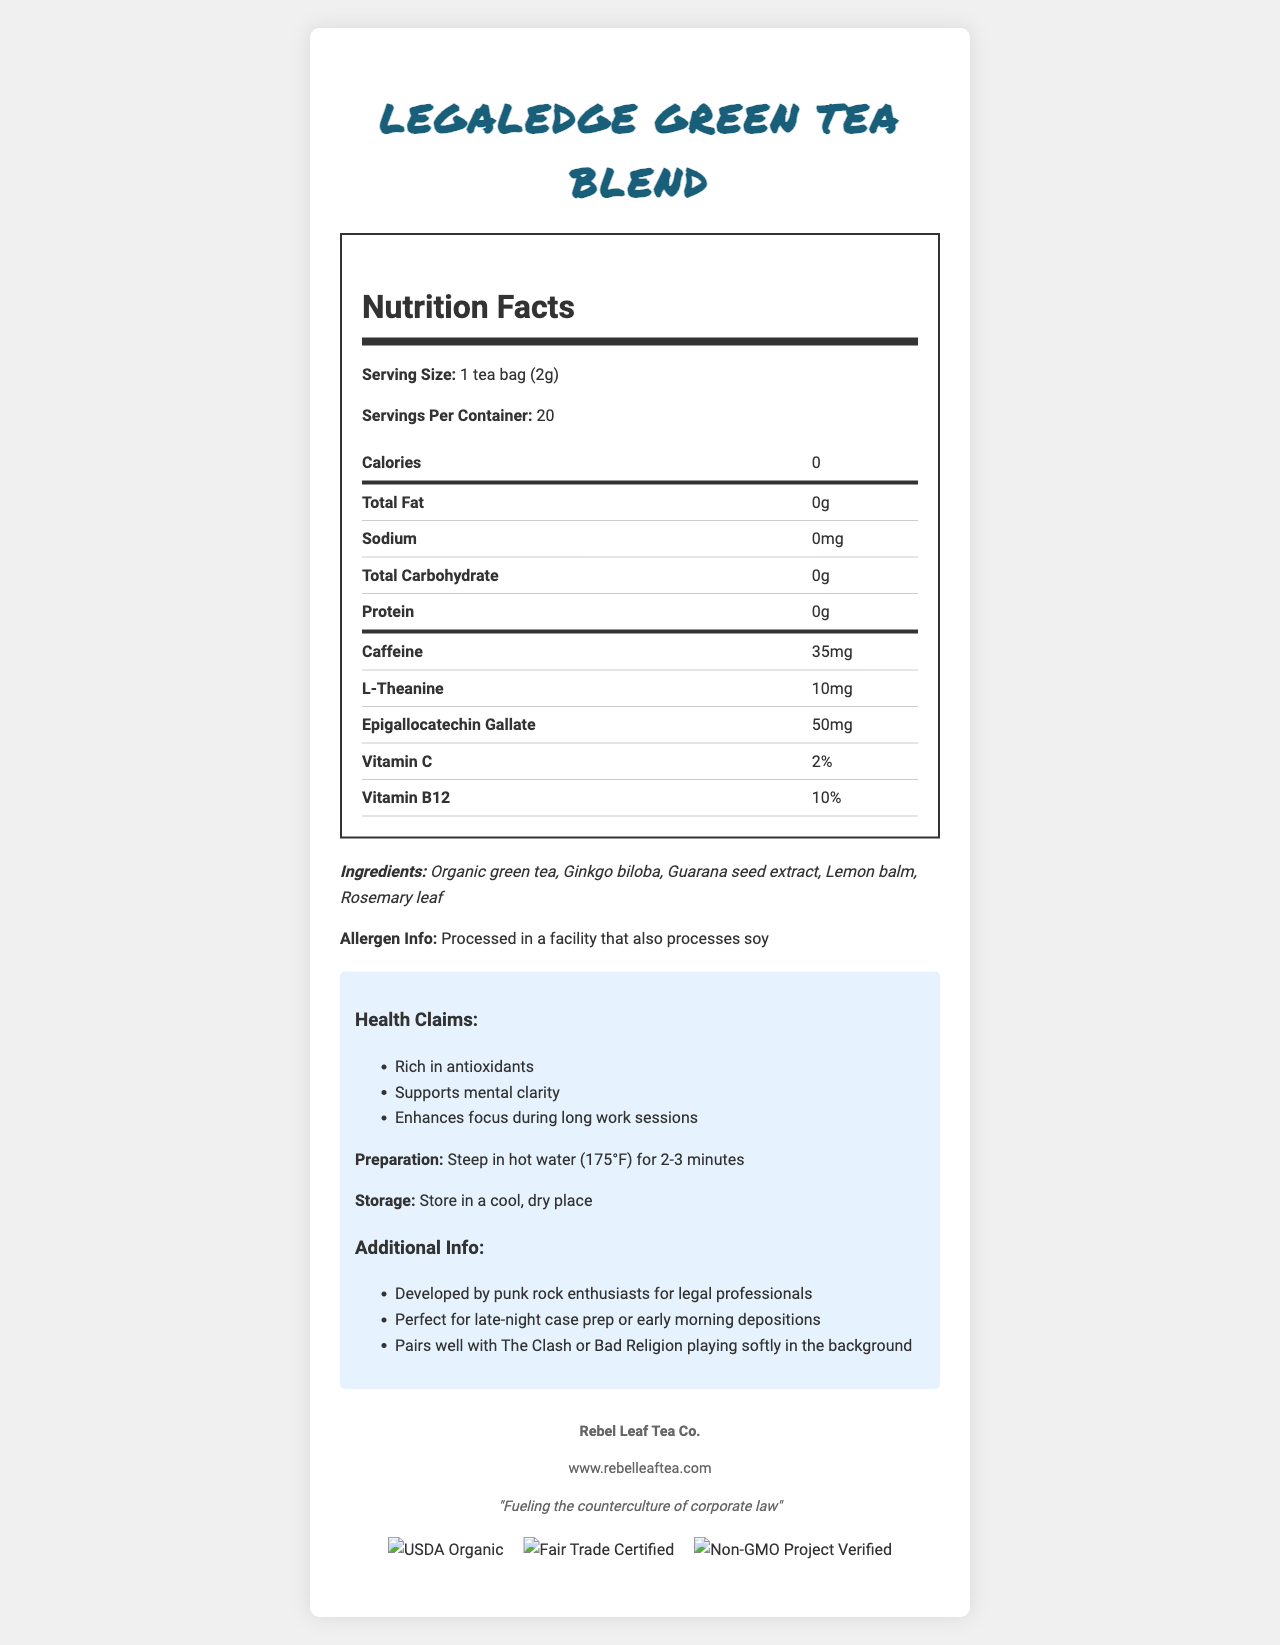What is the serving size for the LegalEdge Green Tea Blend? According to the document, the serving size is indicated as "1 tea bag (2g)".
Answer: 1 tea bag (2g) How many servings are there per container? The document states that there are 20 servings per container.
Answer: 20 How many calories are in one serving of LegalEdge Green Tea Blend? The document shows that each serving contains 0 calories.
Answer: 0 What are the ingredients listed in the LegalEdge Green Tea Blend? The ingredients are listed as "Organic green tea, Ginkgo biloba, Guarana seed extract, Lemon balm, Rosemary leaf".
Answer: Organic green tea, Ginkgo biloba, Guarana seed extract, Lemon balm, Rosemary leaf How much caffeine is in each serving of the tea? The document specifies that each serving contains 35mg of caffeine.
Answer: 35mg Which certifications does the LegalEdge Green Tea Blend have? A. USDA Organic and Fair Trade Certified B. Non-GMO Project Verified and USDA Organic C. All of the above The document shows that the product has certifications for USDA Organic, Fair Trade Certified, and Non-GMO Project Verified.
Answer: C. All of the above What percentage of Vitamin B12 is in each serving? A. 0% B. 2% C. 10% According to the document, each serving contains 10% of Vitamin B12.
Answer: C. 10% Can this tea be prepared using boiling water? Yes/No The preparation instructions specify to steep in hot water (175°F) for 2-3 minutes, which is below boiling point.
Answer: No Summarize the purpose and benefits of the LegalEdge Green Tea Blend. The document highlights the tea as a caffeine-rich, antioxidant-packed beverage designed to aid mental focus and clarity. It includes detailed nutritional information, health claims, ingredients, and preparation instructions.
Answer: The LegalEdge Green Tea Blend is formulated for legal professionals to boost mental clarity and enhance focus during long work sessions. It is rich in antioxidants and contains caffeine, L-Theanine, and Epigallocatechin Gallate. The product is certified organic, fair trade, and non-GMO. What is the main allergen information mentioned? The document states that the tea is processed in a facility that also processes soy.
Answer: Processed in a facility that also processes soy Is this tea developed specifically for musicians? The document indicates it is developed by punk rock enthusiasts for legal professionals, and while it mentions punk rock, it does not specify that it is for musicians.
Answer: Not enough information What is the storage recommendation for the LegalEdge Green Tea Blend? According to the document, the storage recommendation is to store the product in a cool, dry place.
Answer: Store in a cool, dry place 